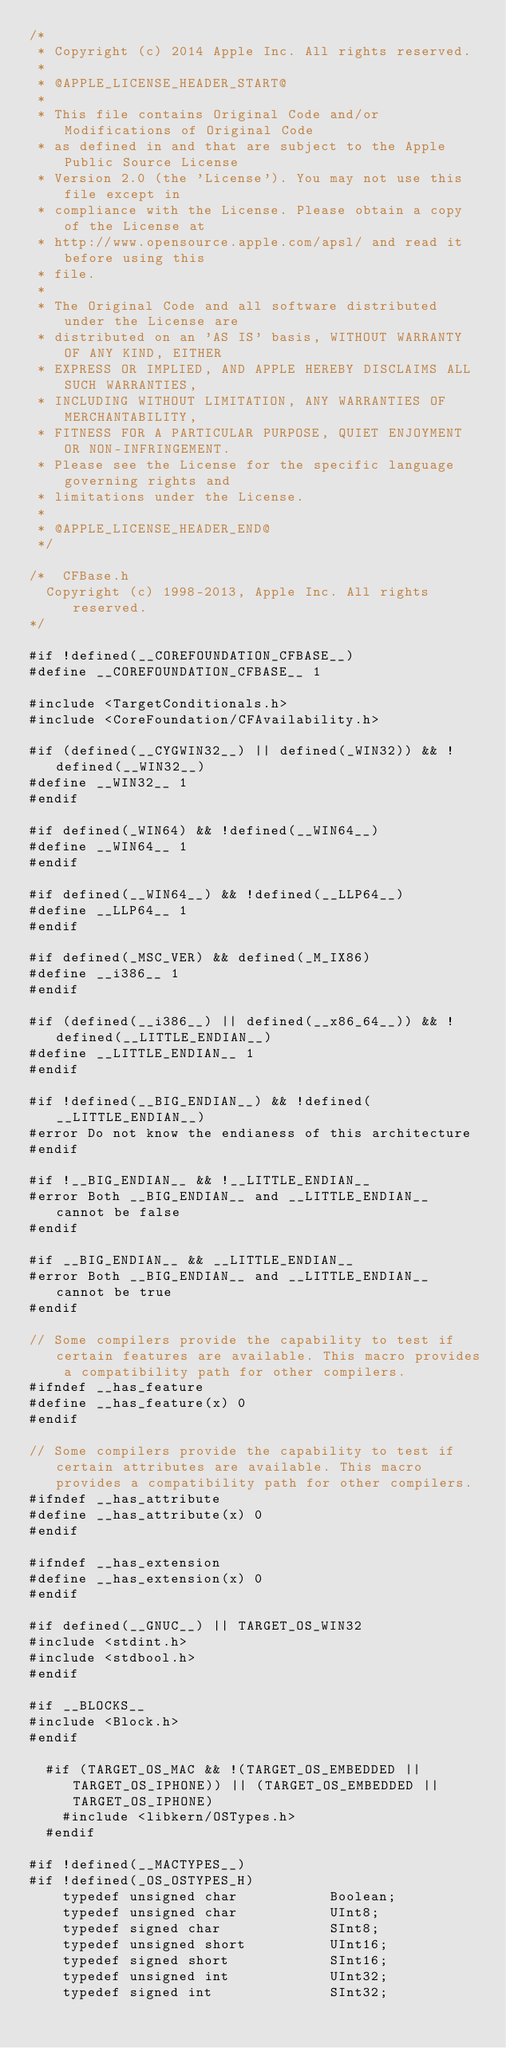Convert code to text. <code><loc_0><loc_0><loc_500><loc_500><_C_>/*
 * Copyright (c) 2014 Apple Inc. All rights reserved.
 *
 * @APPLE_LICENSE_HEADER_START@
 * 
 * This file contains Original Code and/or Modifications of Original Code
 * as defined in and that are subject to the Apple Public Source License
 * Version 2.0 (the 'License'). You may not use this file except in
 * compliance with the License. Please obtain a copy of the License at
 * http://www.opensource.apple.com/apsl/ and read it before using this
 * file.
 * 
 * The Original Code and all software distributed under the License are
 * distributed on an 'AS IS' basis, WITHOUT WARRANTY OF ANY KIND, EITHER
 * EXPRESS OR IMPLIED, AND APPLE HEREBY DISCLAIMS ALL SUCH WARRANTIES,
 * INCLUDING WITHOUT LIMITATION, ANY WARRANTIES OF MERCHANTABILITY,
 * FITNESS FOR A PARTICULAR PURPOSE, QUIET ENJOYMENT OR NON-INFRINGEMENT.
 * Please see the License for the specific language governing rights and
 * limitations under the License.
 * 
 * @APPLE_LICENSE_HEADER_END@
 */

/*	CFBase.h
	Copyright (c) 1998-2013, Apple Inc. All rights reserved.
*/

#if !defined(__COREFOUNDATION_CFBASE__)
#define __COREFOUNDATION_CFBASE__ 1

#include <TargetConditionals.h>
#include <CoreFoundation/CFAvailability.h>

#if (defined(__CYGWIN32__) || defined(_WIN32)) && !defined(__WIN32__)
#define __WIN32__ 1
#endif

#if defined(_WIN64) && !defined(__WIN64__)
#define __WIN64__ 1
#endif

#if defined(__WIN64__) && !defined(__LLP64__)
#define __LLP64__ 1
#endif

#if defined(_MSC_VER) && defined(_M_IX86)
#define __i386__ 1
#endif

#if (defined(__i386__) || defined(__x86_64__)) && !defined(__LITTLE_ENDIAN__)
#define __LITTLE_ENDIAN__ 1
#endif

#if !defined(__BIG_ENDIAN__) && !defined(__LITTLE_ENDIAN__)
#error Do not know the endianess of this architecture
#endif

#if !__BIG_ENDIAN__ && !__LITTLE_ENDIAN__
#error Both __BIG_ENDIAN__ and __LITTLE_ENDIAN__ cannot be false
#endif

#if __BIG_ENDIAN__ && __LITTLE_ENDIAN__
#error Both __BIG_ENDIAN__ and __LITTLE_ENDIAN__ cannot be true
#endif

// Some compilers provide the capability to test if certain features are available. This macro provides a compatibility path for other compilers.
#ifndef __has_feature
#define __has_feature(x) 0
#endif

// Some compilers provide the capability to test if certain attributes are available. This macro provides a compatibility path for other compilers.
#ifndef __has_attribute
#define __has_attribute(x) 0
#endif

#ifndef __has_extension
#define __has_extension(x) 0
#endif

#if defined(__GNUC__) || TARGET_OS_WIN32
#include <stdint.h>
#include <stdbool.h>
#endif

#if __BLOCKS__
#include <Block.h>
#endif

  #if (TARGET_OS_MAC && !(TARGET_OS_EMBEDDED || TARGET_OS_IPHONE)) || (TARGET_OS_EMBEDDED || TARGET_OS_IPHONE)
    #include <libkern/OSTypes.h>
  #endif

#if !defined(__MACTYPES__)
#if !defined(_OS_OSTYPES_H)
    typedef unsigned char           Boolean;
    typedef unsigned char           UInt8;
    typedef signed char             SInt8;
    typedef unsigned short          UInt16;
    typedef signed short            SInt16;
    typedef unsigned int            UInt32;
    typedef signed int              SInt32;</code> 